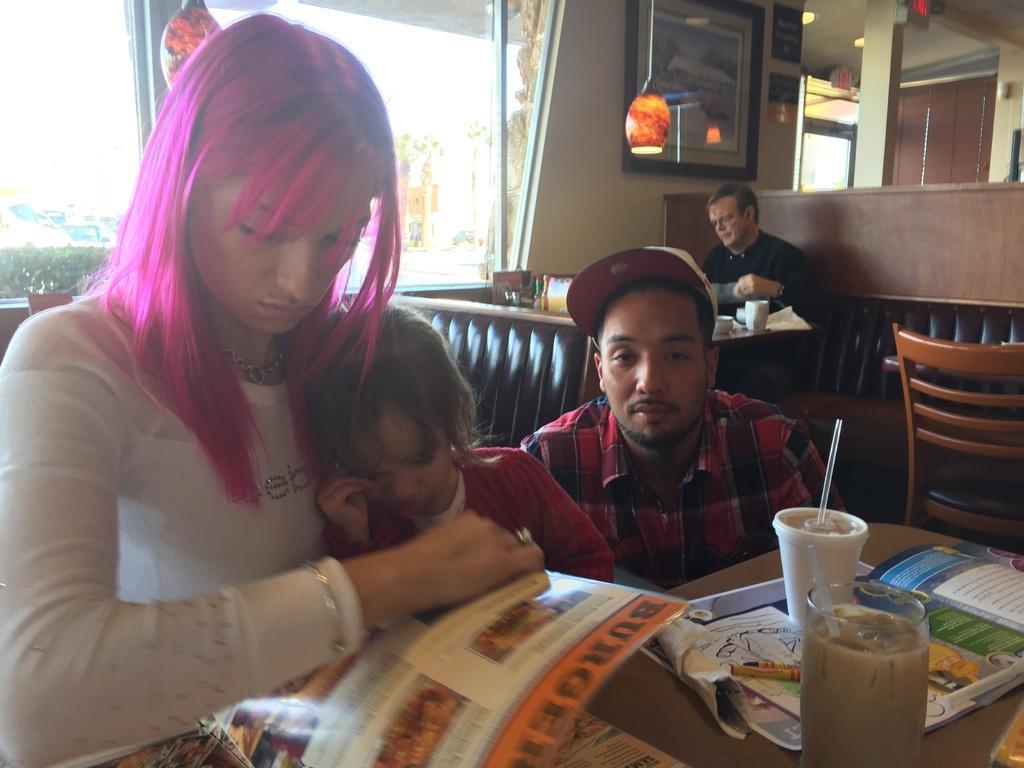Can you describe this image briefly? There are few people sitting on the chair at the table. On the table we can see a glass and a cup,a book. Through window we can see vehicles. 